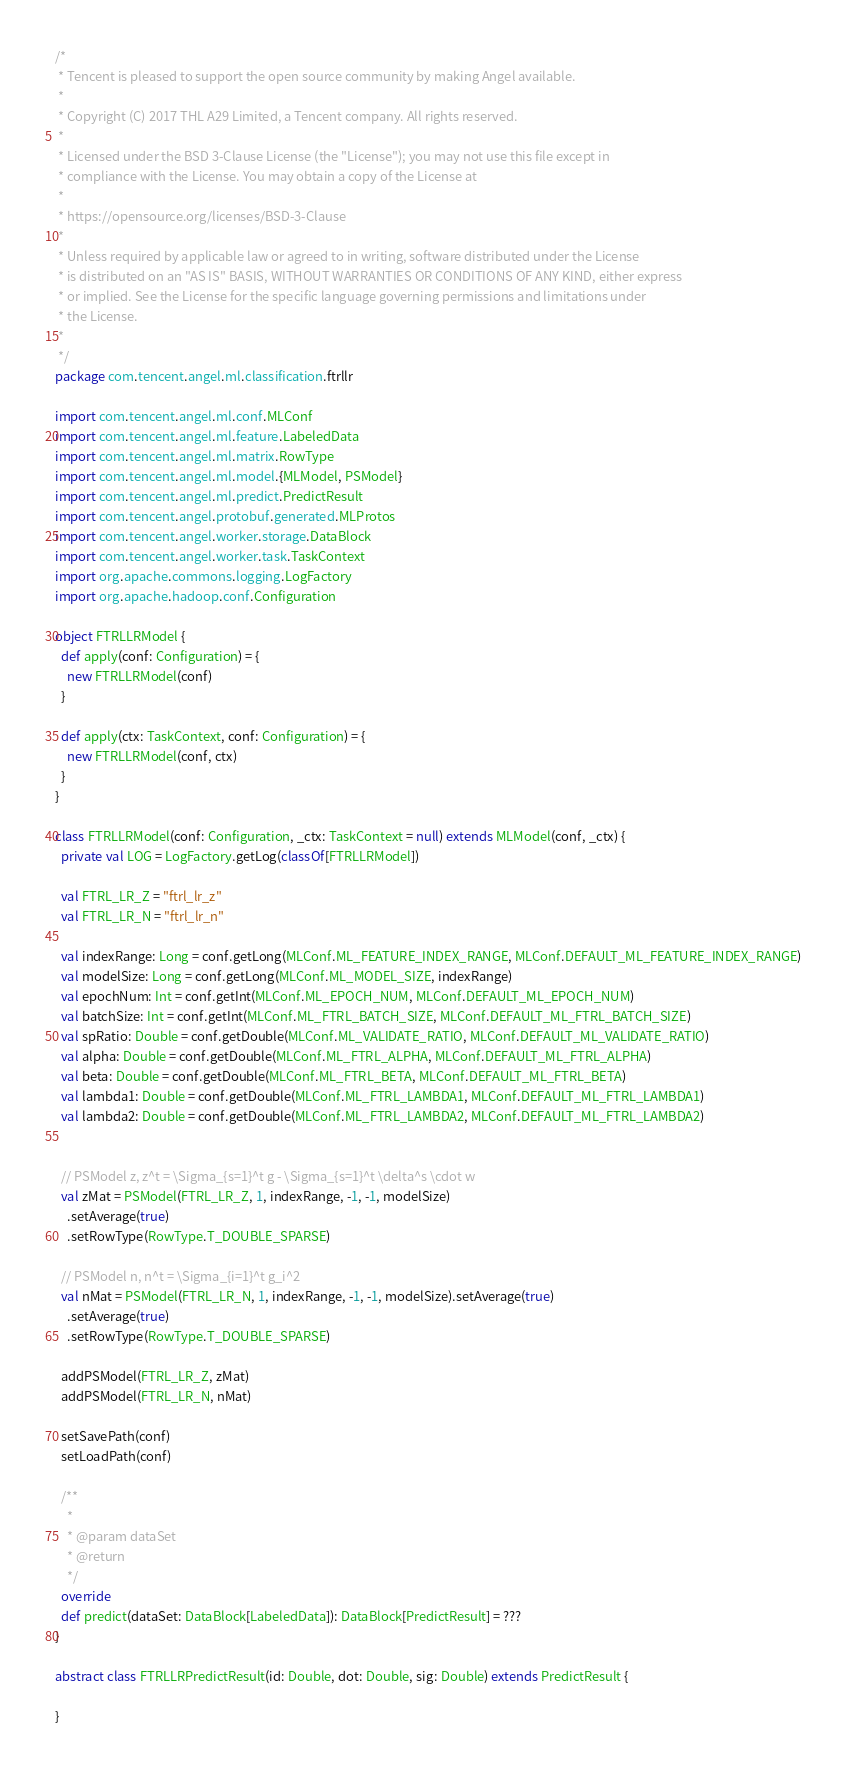<code> <loc_0><loc_0><loc_500><loc_500><_Scala_>/*
 * Tencent is pleased to support the open source community by making Angel available.
 *
 * Copyright (C) 2017 THL A29 Limited, a Tencent company. All rights reserved.
 *
 * Licensed under the BSD 3-Clause License (the "License"); you may not use this file except in
 * compliance with the License. You may obtain a copy of the License at
 *
 * https://opensource.org/licenses/BSD-3-Clause
 *
 * Unless required by applicable law or agreed to in writing, software distributed under the License
 * is distributed on an "AS IS" BASIS, WITHOUT WARRANTIES OR CONDITIONS OF ANY KIND, either express
 * or implied. See the License for the specific language governing permissions and limitations under
 * the License.
 *
 */
package com.tencent.angel.ml.classification.ftrllr

import com.tencent.angel.ml.conf.MLConf
import com.tencent.angel.ml.feature.LabeledData
import com.tencent.angel.ml.matrix.RowType
import com.tencent.angel.ml.model.{MLModel, PSModel}
import com.tencent.angel.ml.predict.PredictResult
import com.tencent.angel.protobuf.generated.MLProtos
import com.tencent.angel.worker.storage.DataBlock
import com.tencent.angel.worker.task.TaskContext
import org.apache.commons.logging.LogFactory
import org.apache.hadoop.conf.Configuration

object FTRLLRModel {
  def apply(conf: Configuration) = {
    new FTRLLRModel(conf)
  }

  def apply(ctx: TaskContext, conf: Configuration) = {
    new FTRLLRModel(conf, ctx)
  }
}

class FTRLLRModel(conf: Configuration, _ctx: TaskContext = null) extends MLModel(conf, _ctx) {
  private val LOG = LogFactory.getLog(classOf[FTRLLRModel])

  val FTRL_LR_Z = "ftrl_lr_z"
  val FTRL_LR_N = "ftrl_lr_n"

  val indexRange: Long = conf.getLong(MLConf.ML_FEATURE_INDEX_RANGE, MLConf.DEFAULT_ML_FEATURE_INDEX_RANGE)
  val modelSize: Long = conf.getLong(MLConf.ML_MODEL_SIZE, indexRange)
  val epochNum: Int = conf.getInt(MLConf.ML_EPOCH_NUM, MLConf.DEFAULT_ML_EPOCH_NUM)
  val batchSize: Int = conf.getInt(MLConf.ML_FTRL_BATCH_SIZE, MLConf.DEFAULT_ML_FTRL_BATCH_SIZE)
  val spRatio: Double = conf.getDouble(MLConf.ML_VALIDATE_RATIO, MLConf.DEFAULT_ML_VALIDATE_RATIO)
  val alpha: Double = conf.getDouble(MLConf.ML_FTRL_ALPHA, MLConf.DEFAULT_ML_FTRL_ALPHA)
  val beta: Double = conf.getDouble(MLConf.ML_FTRL_BETA, MLConf.DEFAULT_ML_FTRL_BETA)
  val lambda1: Double = conf.getDouble(MLConf.ML_FTRL_LAMBDA1, MLConf.DEFAULT_ML_FTRL_LAMBDA1)
  val lambda2: Double = conf.getDouble(MLConf.ML_FTRL_LAMBDA2, MLConf.DEFAULT_ML_FTRL_LAMBDA2)


  // PSModel z, z^t = \Sigma_{s=1}^t g - \Sigma_{s=1}^t \delta^s \cdot w
  val zMat = PSModel(FTRL_LR_Z, 1, indexRange, -1, -1, modelSize)
    .setAverage(true)
    .setRowType(RowType.T_DOUBLE_SPARSE)

  // PSModel n, n^t = \Sigma_{i=1}^t g_i^2
  val nMat = PSModel(FTRL_LR_N, 1, indexRange, -1, -1, modelSize).setAverage(true)
    .setAverage(true)
    .setRowType(RowType.T_DOUBLE_SPARSE)

  addPSModel(FTRL_LR_Z, zMat)
  addPSModel(FTRL_LR_N, nMat)

  setSavePath(conf)
  setLoadPath(conf)

  /**
    *
    * @param dataSet
    * @return
    */
  override
  def predict(dataSet: DataBlock[LabeledData]): DataBlock[PredictResult] = ???
}

abstract class FTRLLRPredictResult(id: Double, dot: Double, sig: Double) extends PredictResult {

}
</code> 